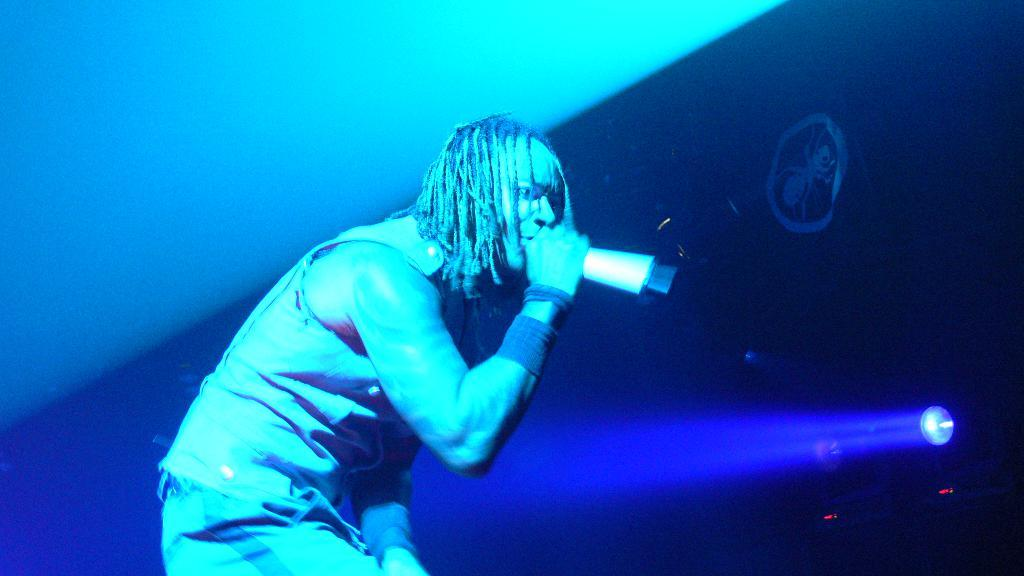What is the person in the image doing? There is a person performing on the stage. What is the person holding while performing? The person is holding a microphone in their hand. What can be seen on the right side of the stage? There are lights on the right side of the stage. What additional detail can be observed in the image? There is a symbol visible in the image. What is the price of the glass that the person is holding on stage? The person is not holding a glass in the image; they are holding a microphone. 